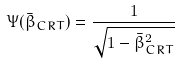Convert formula to latex. <formula><loc_0><loc_0><loc_500><loc_500>\Psi ( \bar { \beta } _ { C R T } ) = \frac { 1 } { \sqrt { 1 - \bar { \beta } _ { C R T } ^ { 2 } } }</formula> 